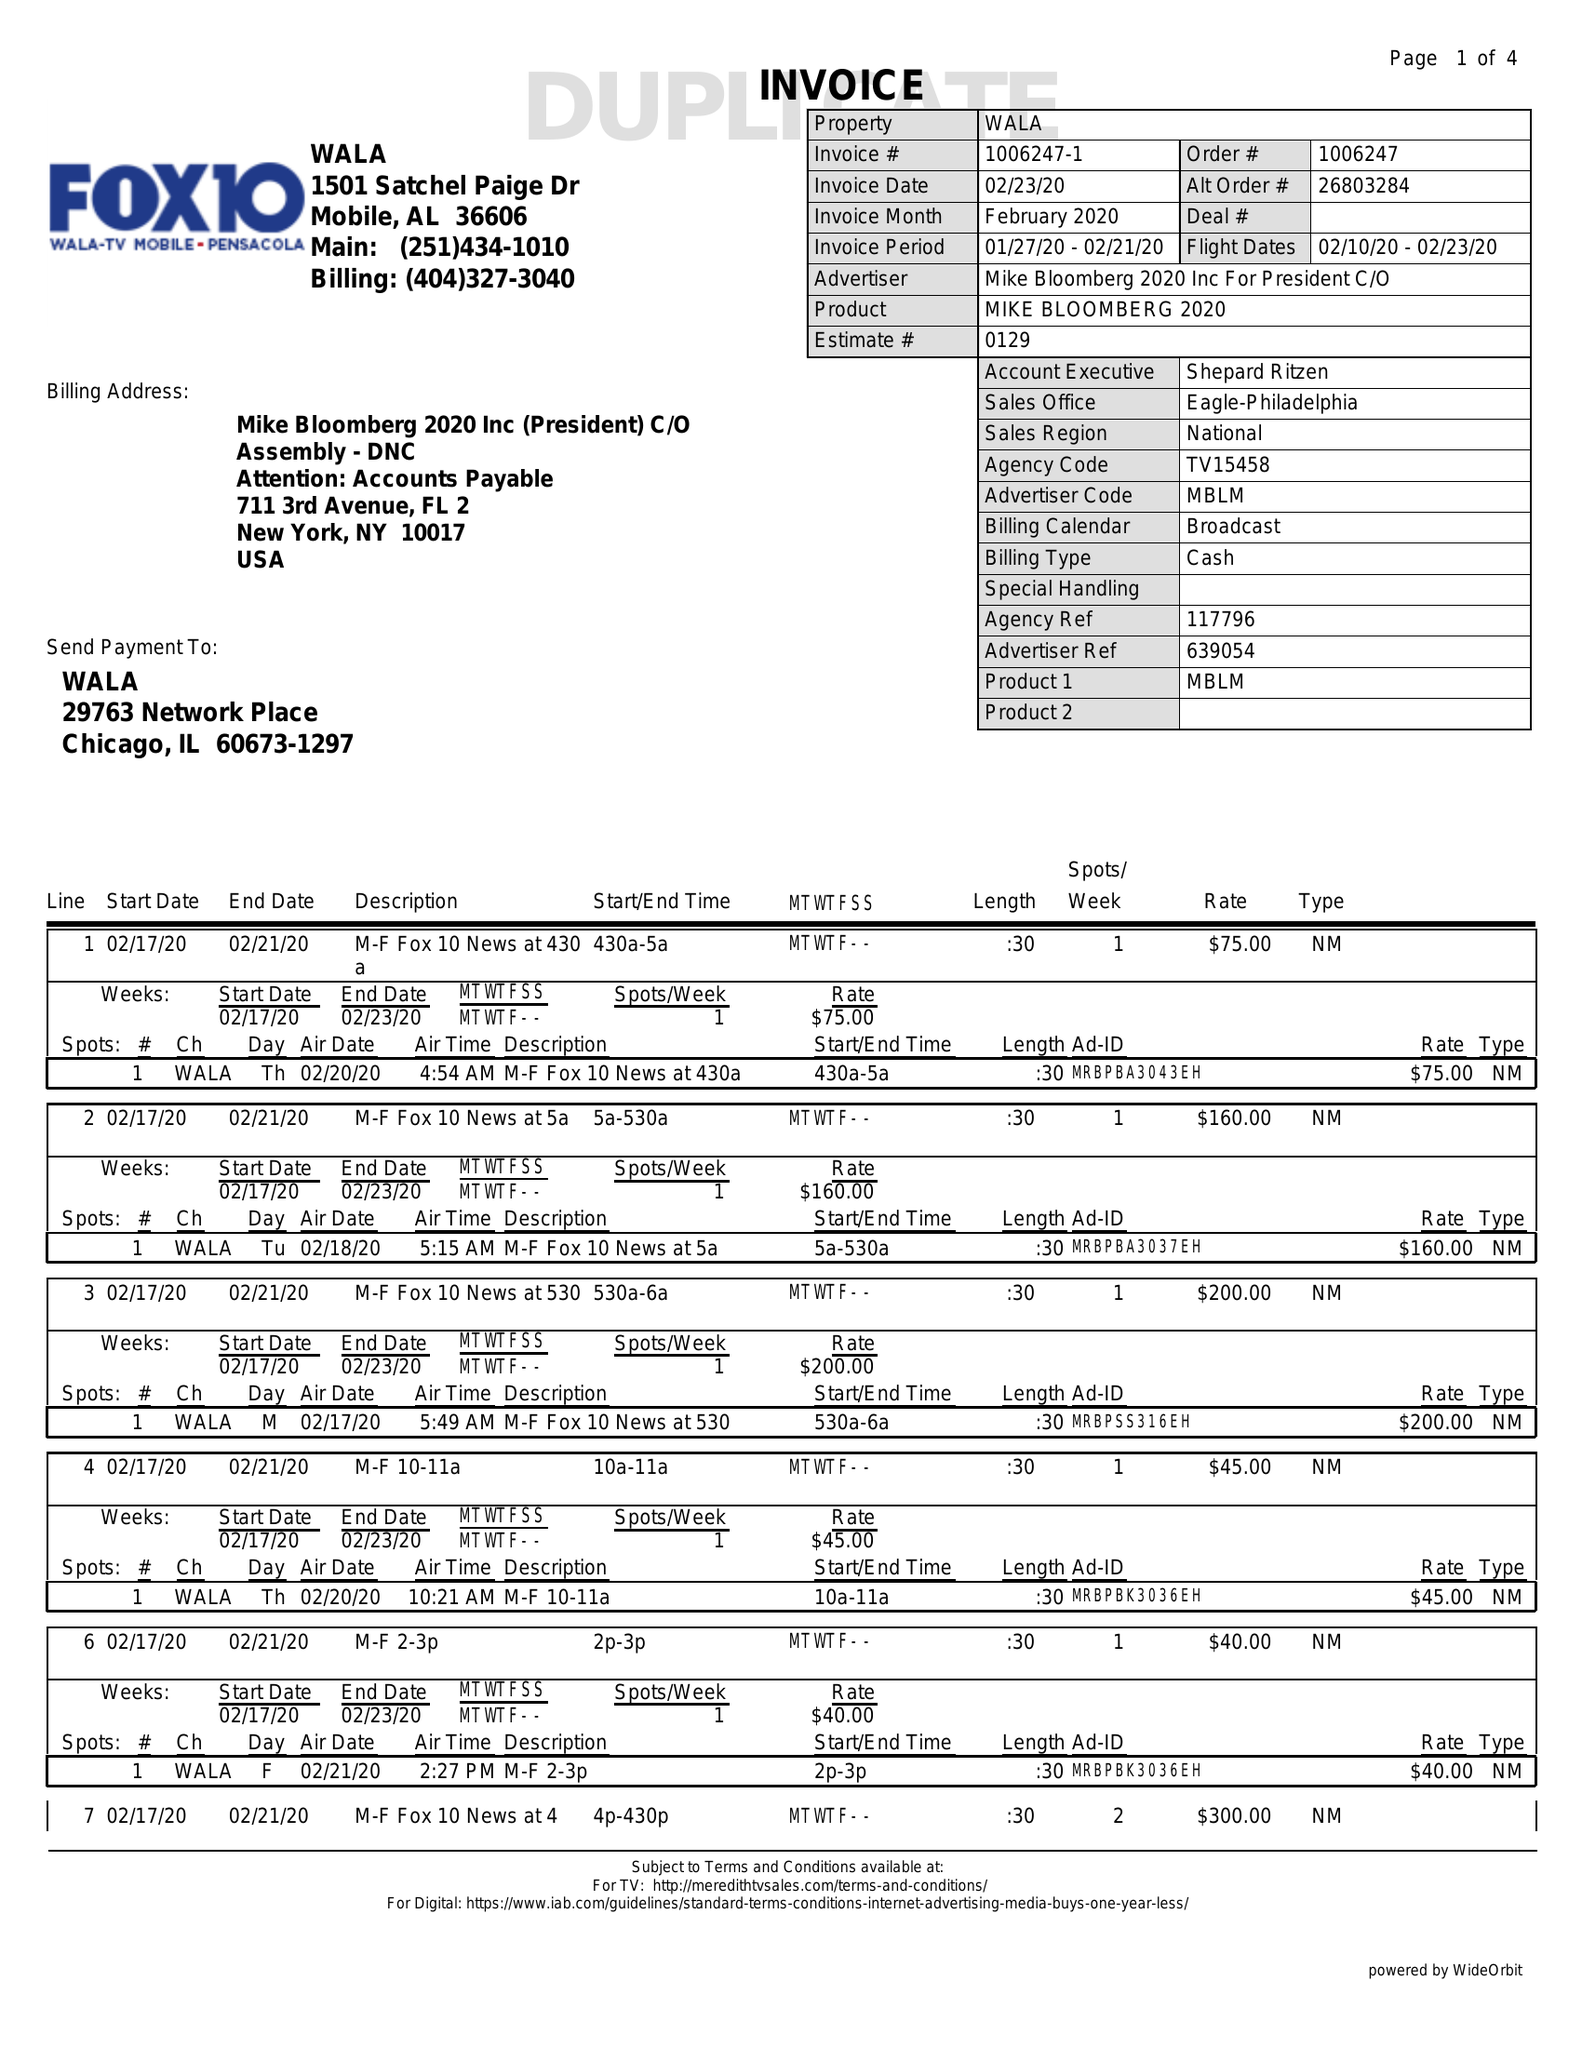What is the value for the contract_num?
Answer the question using a single word or phrase. 1006247 